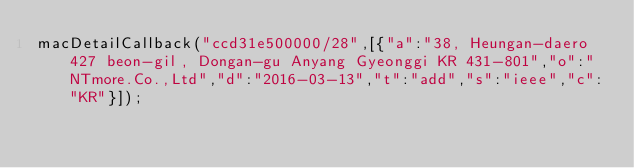<code> <loc_0><loc_0><loc_500><loc_500><_JavaScript_>macDetailCallback("ccd31e500000/28",[{"a":"38, Heungan-daero 427 beon-gil, Dongan-gu Anyang Gyeonggi KR 431-801","o":"NTmore.Co.,Ltd","d":"2016-03-13","t":"add","s":"ieee","c":"KR"}]);
</code> 